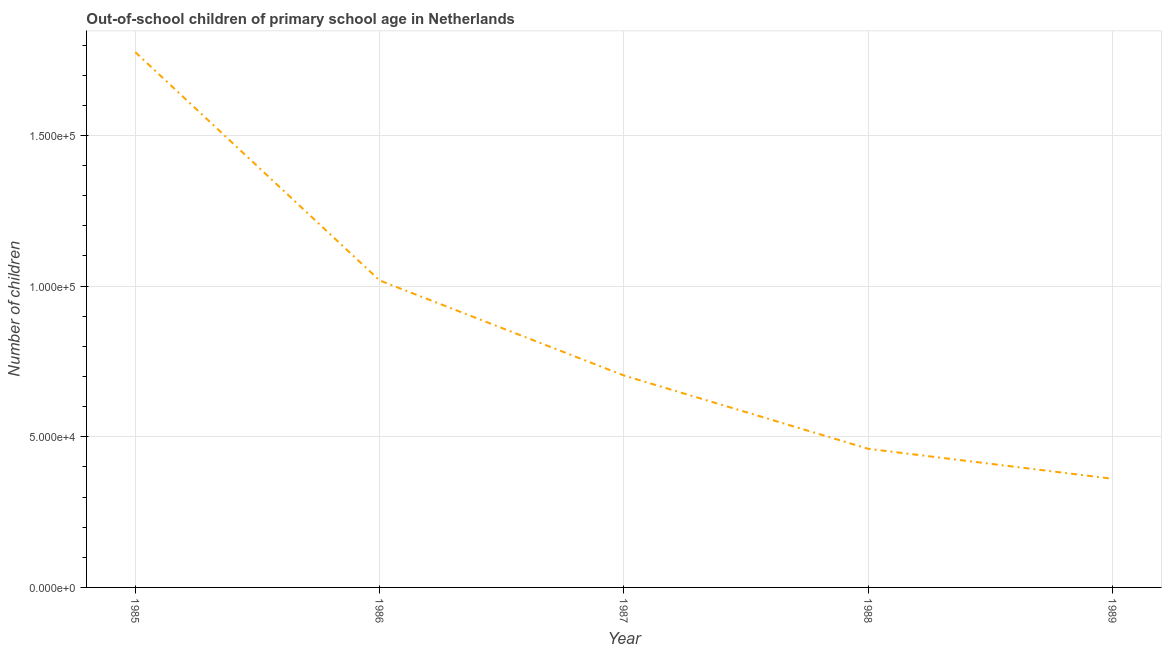What is the number of out-of-school children in 1988?
Give a very brief answer. 4.60e+04. Across all years, what is the maximum number of out-of-school children?
Keep it short and to the point. 1.78e+05. Across all years, what is the minimum number of out-of-school children?
Ensure brevity in your answer.  3.61e+04. In which year was the number of out-of-school children maximum?
Keep it short and to the point. 1985. What is the sum of the number of out-of-school children?
Ensure brevity in your answer.  4.32e+05. What is the difference between the number of out-of-school children in 1986 and 1988?
Offer a terse response. 5.59e+04. What is the average number of out-of-school children per year?
Make the answer very short. 8.64e+04. What is the median number of out-of-school children?
Give a very brief answer. 7.03e+04. What is the ratio of the number of out-of-school children in 1986 to that in 1989?
Provide a succinct answer. 2.83. Is the number of out-of-school children in 1988 less than that in 1989?
Your response must be concise. No. What is the difference between the highest and the second highest number of out-of-school children?
Give a very brief answer. 7.58e+04. Is the sum of the number of out-of-school children in 1986 and 1987 greater than the maximum number of out-of-school children across all years?
Keep it short and to the point. No. What is the difference between the highest and the lowest number of out-of-school children?
Your response must be concise. 1.42e+05. How many lines are there?
Make the answer very short. 1. What is the title of the graph?
Give a very brief answer. Out-of-school children of primary school age in Netherlands. What is the label or title of the X-axis?
Make the answer very short. Year. What is the label or title of the Y-axis?
Keep it short and to the point. Number of children. What is the Number of children in 1985?
Provide a succinct answer. 1.78e+05. What is the Number of children of 1986?
Offer a very short reply. 1.02e+05. What is the Number of children of 1987?
Offer a terse response. 7.03e+04. What is the Number of children in 1988?
Ensure brevity in your answer.  4.60e+04. What is the Number of children in 1989?
Provide a short and direct response. 3.61e+04. What is the difference between the Number of children in 1985 and 1986?
Ensure brevity in your answer.  7.58e+04. What is the difference between the Number of children in 1985 and 1987?
Your answer should be compact. 1.07e+05. What is the difference between the Number of children in 1985 and 1988?
Your answer should be very brief. 1.32e+05. What is the difference between the Number of children in 1985 and 1989?
Your answer should be very brief. 1.42e+05. What is the difference between the Number of children in 1986 and 1987?
Offer a terse response. 3.15e+04. What is the difference between the Number of children in 1986 and 1988?
Your answer should be compact. 5.59e+04. What is the difference between the Number of children in 1986 and 1989?
Provide a short and direct response. 6.58e+04. What is the difference between the Number of children in 1987 and 1988?
Ensure brevity in your answer.  2.43e+04. What is the difference between the Number of children in 1987 and 1989?
Offer a very short reply. 3.43e+04. What is the difference between the Number of children in 1988 and 1989?
Make the answer very short. 9939. What is the ratio of the Number of children in 1985 to that in 1986?
Your answer should be compact. 1.74. What is the ratio of the Number of children in 1985 to that in 1987?
Keep it short and to the point. 2.53. What is the ratio of the Number of children in 1985 to that in 1988?
Your answer should be very brief. 3.86. What is the ratio of the Number of children in 1985 to that in 1989?
Ensure brevity in your answer.  4.93. What is the ratio of the Number of children in 1986 to that in 1987?
Provide a short and direct response. 1.45. What is the ratio of the Number of children in 1986 to that in 1988?
Give a very brief answer. 2.21. What is the ratio of the Number of children in 1986 to that in 1989?
Your answer should be compact. 2.83. What is the ratio of the Number of children in 1987 to that in 1988?
Your answer should be compact. 1.53. What is the ratio of the Number of children in 1987 to that in 1989?
Offer a very short reply. 1.95. What is the ratio of the Number of children in 1988 to that in 1989?
Ensure brevity in your answer.  1.28. 